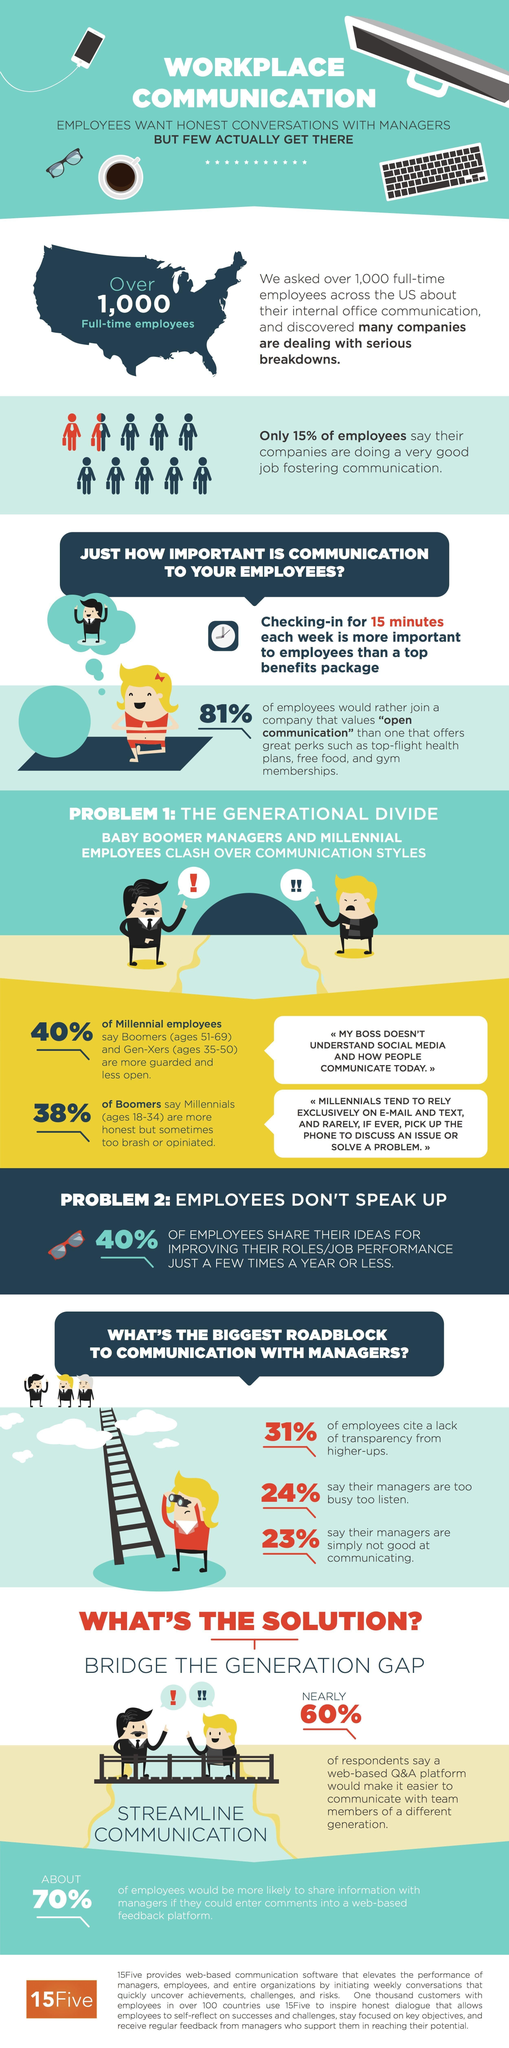Highlight a few significant elements in this photo. According to a recent survey, 24% of employees claim that their managers are too busy to listen to them. A recent survey found that only 15% of employees believe that their companies are doing an excellent job in fostering communication. Thirty-one percent of employees cite a lack of transparency from higher-ups as a major concern. 